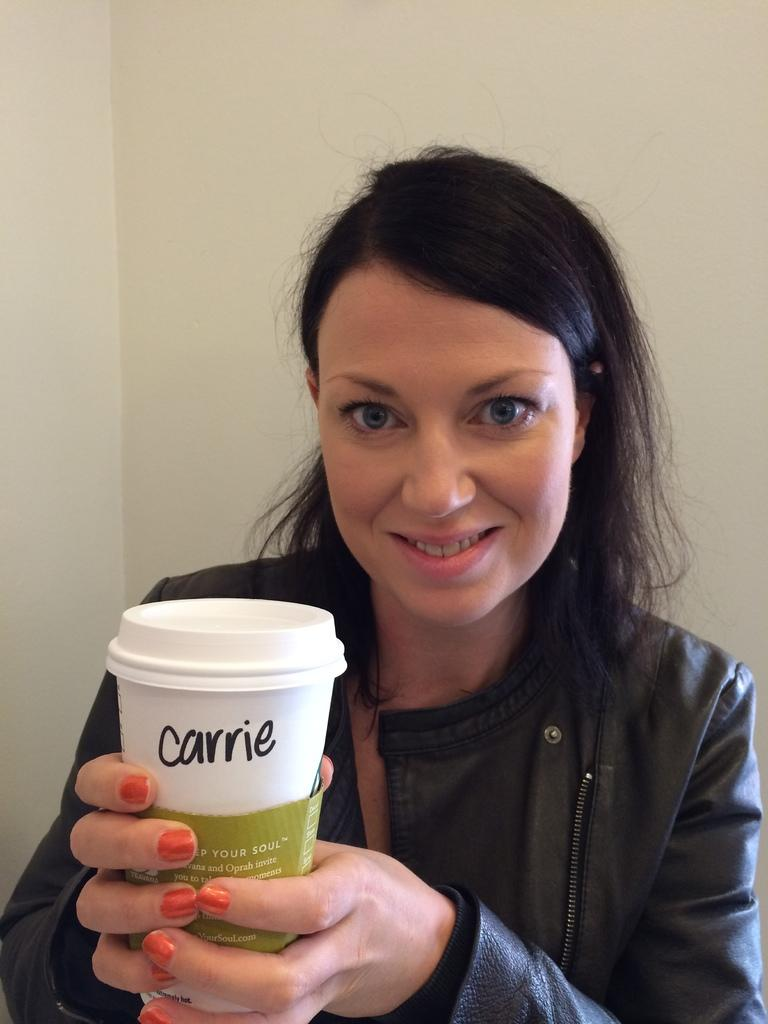Who is present in the image? There is a woman in the image. What is the woman holding in the image? The woman is holding a cup. What can be seen in the background of the image? There is a wall in the background of the image. What book or guide is the woman using to help her in the image? There is no book or guide present in the image; the woman is simply holding a cup. 